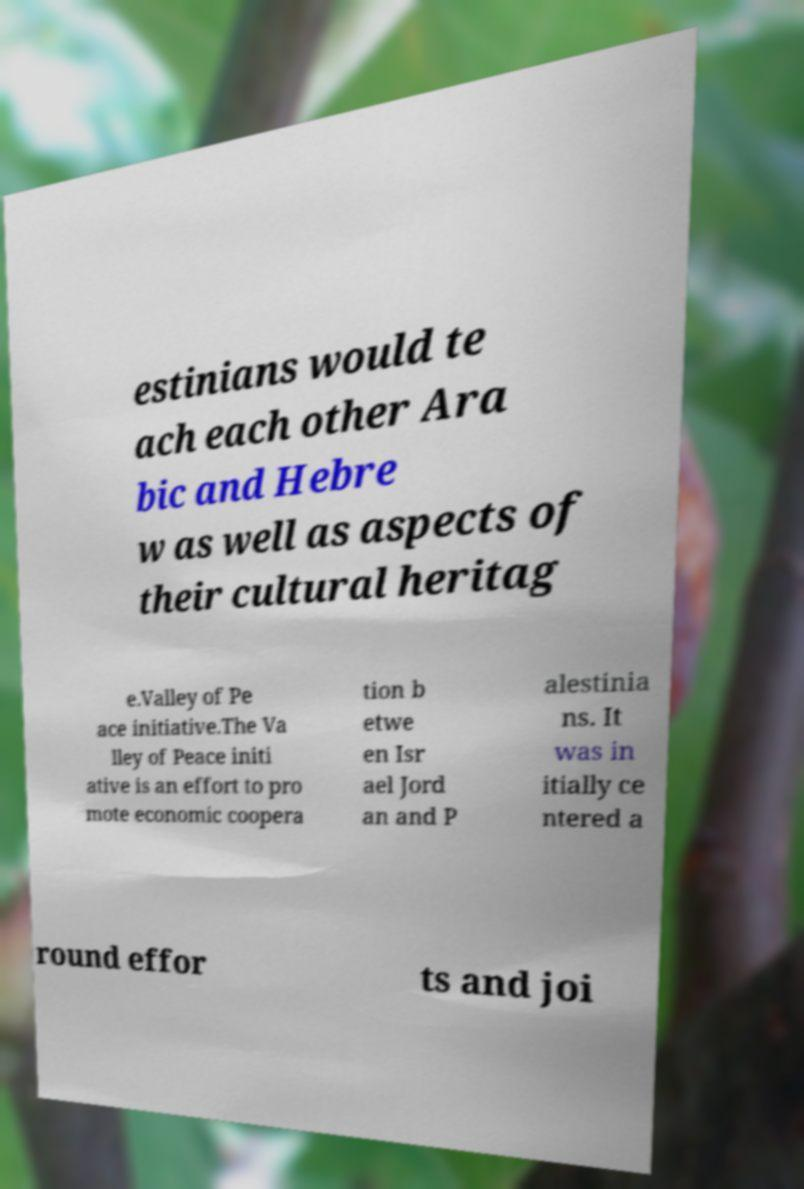There's text embedded in this image that I need extracted. Can you transcribe it verbatim? estinians would te ach each other Ara bic and Hebre w as well as aspects of their cultural heritag e.Valley of Pe ace initiative.The Va lley of Peace initi ative is an effort to pro mote economic coopera tion b etwe en Isr ael Jord an and P alestinia ns. It was in itially ce ntered a round effor ts and joi 